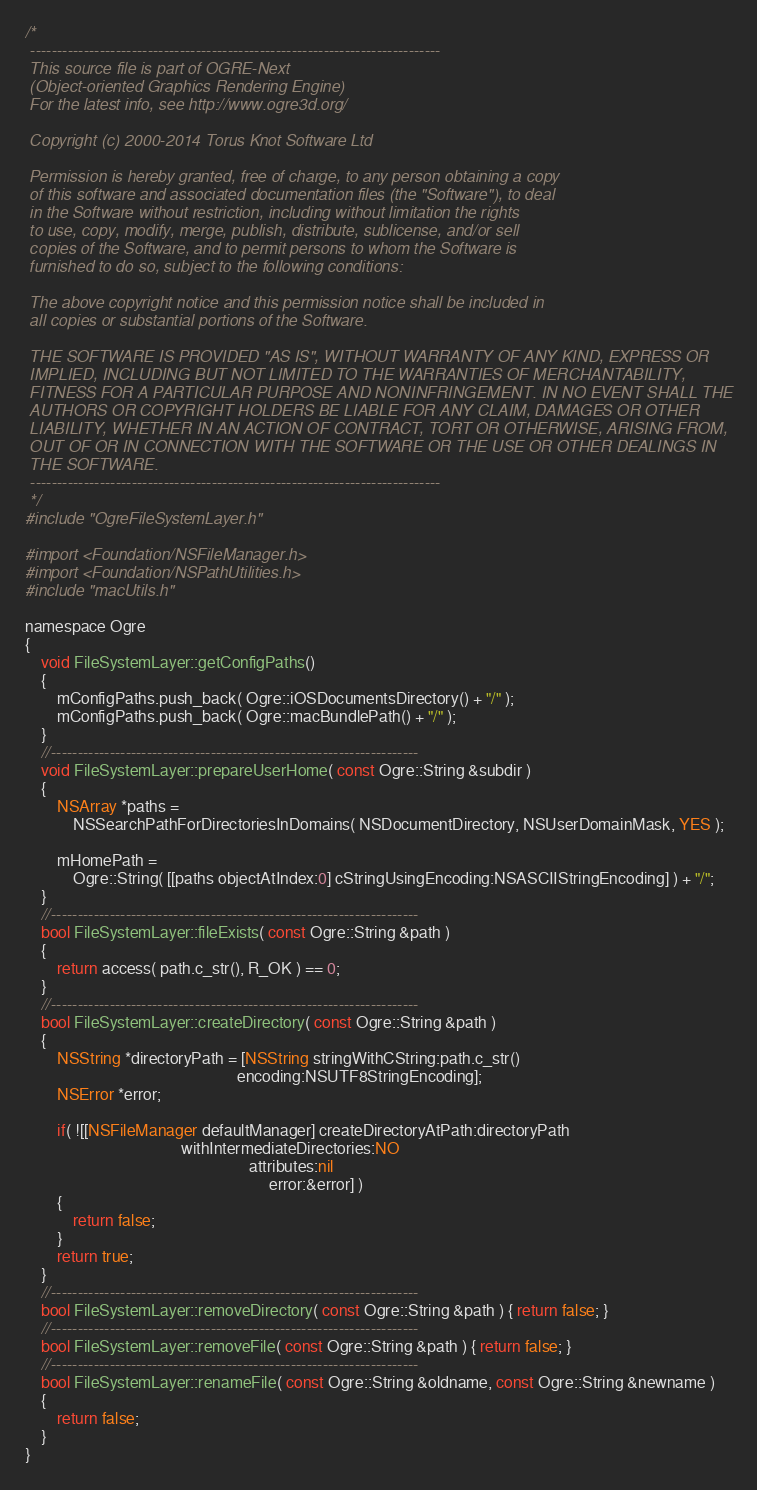Convert code to text. <code><loc_0><loc_0><loc_500><loc_500><_ObjectiveC_>/*
 -----------------------------------------------------------------------------
 This source file is part of OGRE-Next
 (Object-oriented Graphics Rendering Engine)
 For the latest info, see http://www.ogre3d.org/

 Copyright (c) 2000-2014 Torus Knot Software Ltd

 Permission is hereby granted, free of charge, to any person obtaining a copy
 of this software and associated documentation files (the "Software"), to deal
 in the Software without restriction, including without limitation the rights
 to use, copy, modify, merge, publish, distribute, sublicense, and/or sell
 copies of the Software, and to permit persons to whom the Software is
 furnished to do so, subject to the following conditions:

 The above copyright notice and this permission notice shall be included in
 all copies or substantial portions of the Software.

 THE SOFTWARE IS PROVIDED "AS IS", WITHOUT WARRANTY OF ANY KIND, EXPRESS OR
 IMPLIED, INCLUDING BUT NOT LIMITED TO THE WARRANTIES OF MERCHANTABILITY,
 FITNESS FOR A PARTICULAR PURPOSE AND NONINFRINGEMENT. IN NO EVENT SHALL THE
 AUTHORS OR COPYRIGHT HOLDERS BE LIABLE FOR ANY CLAIM, DAMAGES OR OTHER
 LIABILITY, WHETHER IN AN ACTION OF CONTRACT, TORT OR OTHERWISE, ARISING FROM,
 OUT OF OR IN CONNECTION WITH THE SOFTWARE OR THE USE OR OTHER DEALINGS IN
 THE SOFTWARE.
 -----------------------------------------------------------------------------
 */
#include "OgreFileSystemLayer.h"

#import <Foundation/NSFileManager.h>
#import <Foundation/NSPathUtilities.h>
#include "macUtils.h"

namespace Ogre
{
    void FileSystemLayer::getConfigPaths()
    {
        mConfigPaths.push_back( Ogre::iOSDocumentsDirectory() + "/" );
        mConfigPaths.push_back( Ogre::macBundlePath() + "/" );
    }
    //---------------------------------------------------------------------
    void FileSystemLayer::prepareUserHome( const Ogre::String &subdir )
    {
        NSArray *paths =
            NSSearchPathForDirectoriesInDomains( NSDocumentDirectory, NSUserDomainMask, YES );

        mHomePath =
            Ogre::String( [[paths objectAtIndex:0] cStringUsingEncoding:NSASCIIStringEncoding] ) + "/";
    }
    //---------------------------------------------------------------------
    bool FileSystemLayer::fileExists( const Ogre::String &path )
    {
        return access( path.c_str(), R_OK ) == 0;
    }
    //---------------------------------------------------------------------
    bool FileSystemLayer::createDirectory( const Ogre::String &path )
    {
        NSString *directoryPath = [NSString stringWithCString:path.c_str()
                                                     encoding:NSUTF8StringEncoding];
        NSError *error;

        if( ![[NSFileManager defaultManager] createDirectoryAtPath:directoryPath
                                       withIntermediateDirectories:NO
                                                        attributes:nil
                                                             error:&error] )
        {
            return false;
        }
        return true;
    }
    //---------------------------------------------------------------------
    bool FileSystemLayer::removeDirectory( const Ogre::String &path ) { return false; }
    //---------------------------------------------------------------------
    bool FileSystemLayer::removeFile( const Ogre::String &path ) { return false; }
    //---------------------------------------------------------------------
    bool FileSystemLayer::renameFile( const Ogre::String &oldname, const Ogre::String &newname )
    {
        return false;
    }
}
</code> 